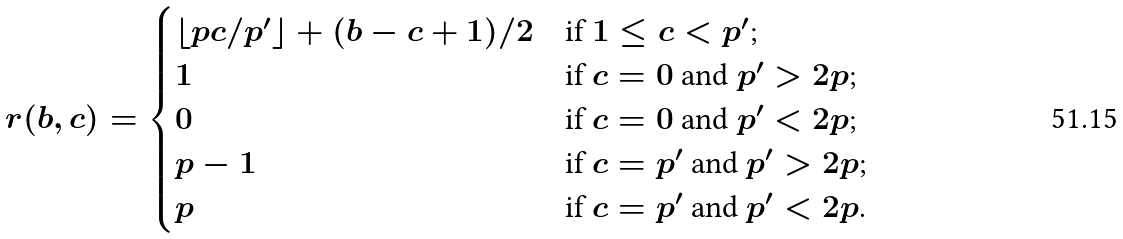<formula> <loc_0><loc_0><loc_500><loc_500>r ( b , c ) = \begin{cases} \lfloor p c / p ^ { \prime } \rfloor + ( b - c + 1 ) / 2 & \text {if $1\leq c<p^{\prime}$;} \\ 1 & \text {if $c=0$ and $p^{\prime}>2p$;} \\ 0 & \text {if $c=0$ and $p^{\prime}<2p$;} \\ p - 1 & \text {if $c=p^{\prime}$ and $p^{\prime}>2p$;} \\ p & \text {if $c=p^{\prime}$ and $p^{\prime}<2p$.} \end{cases}</formula> 